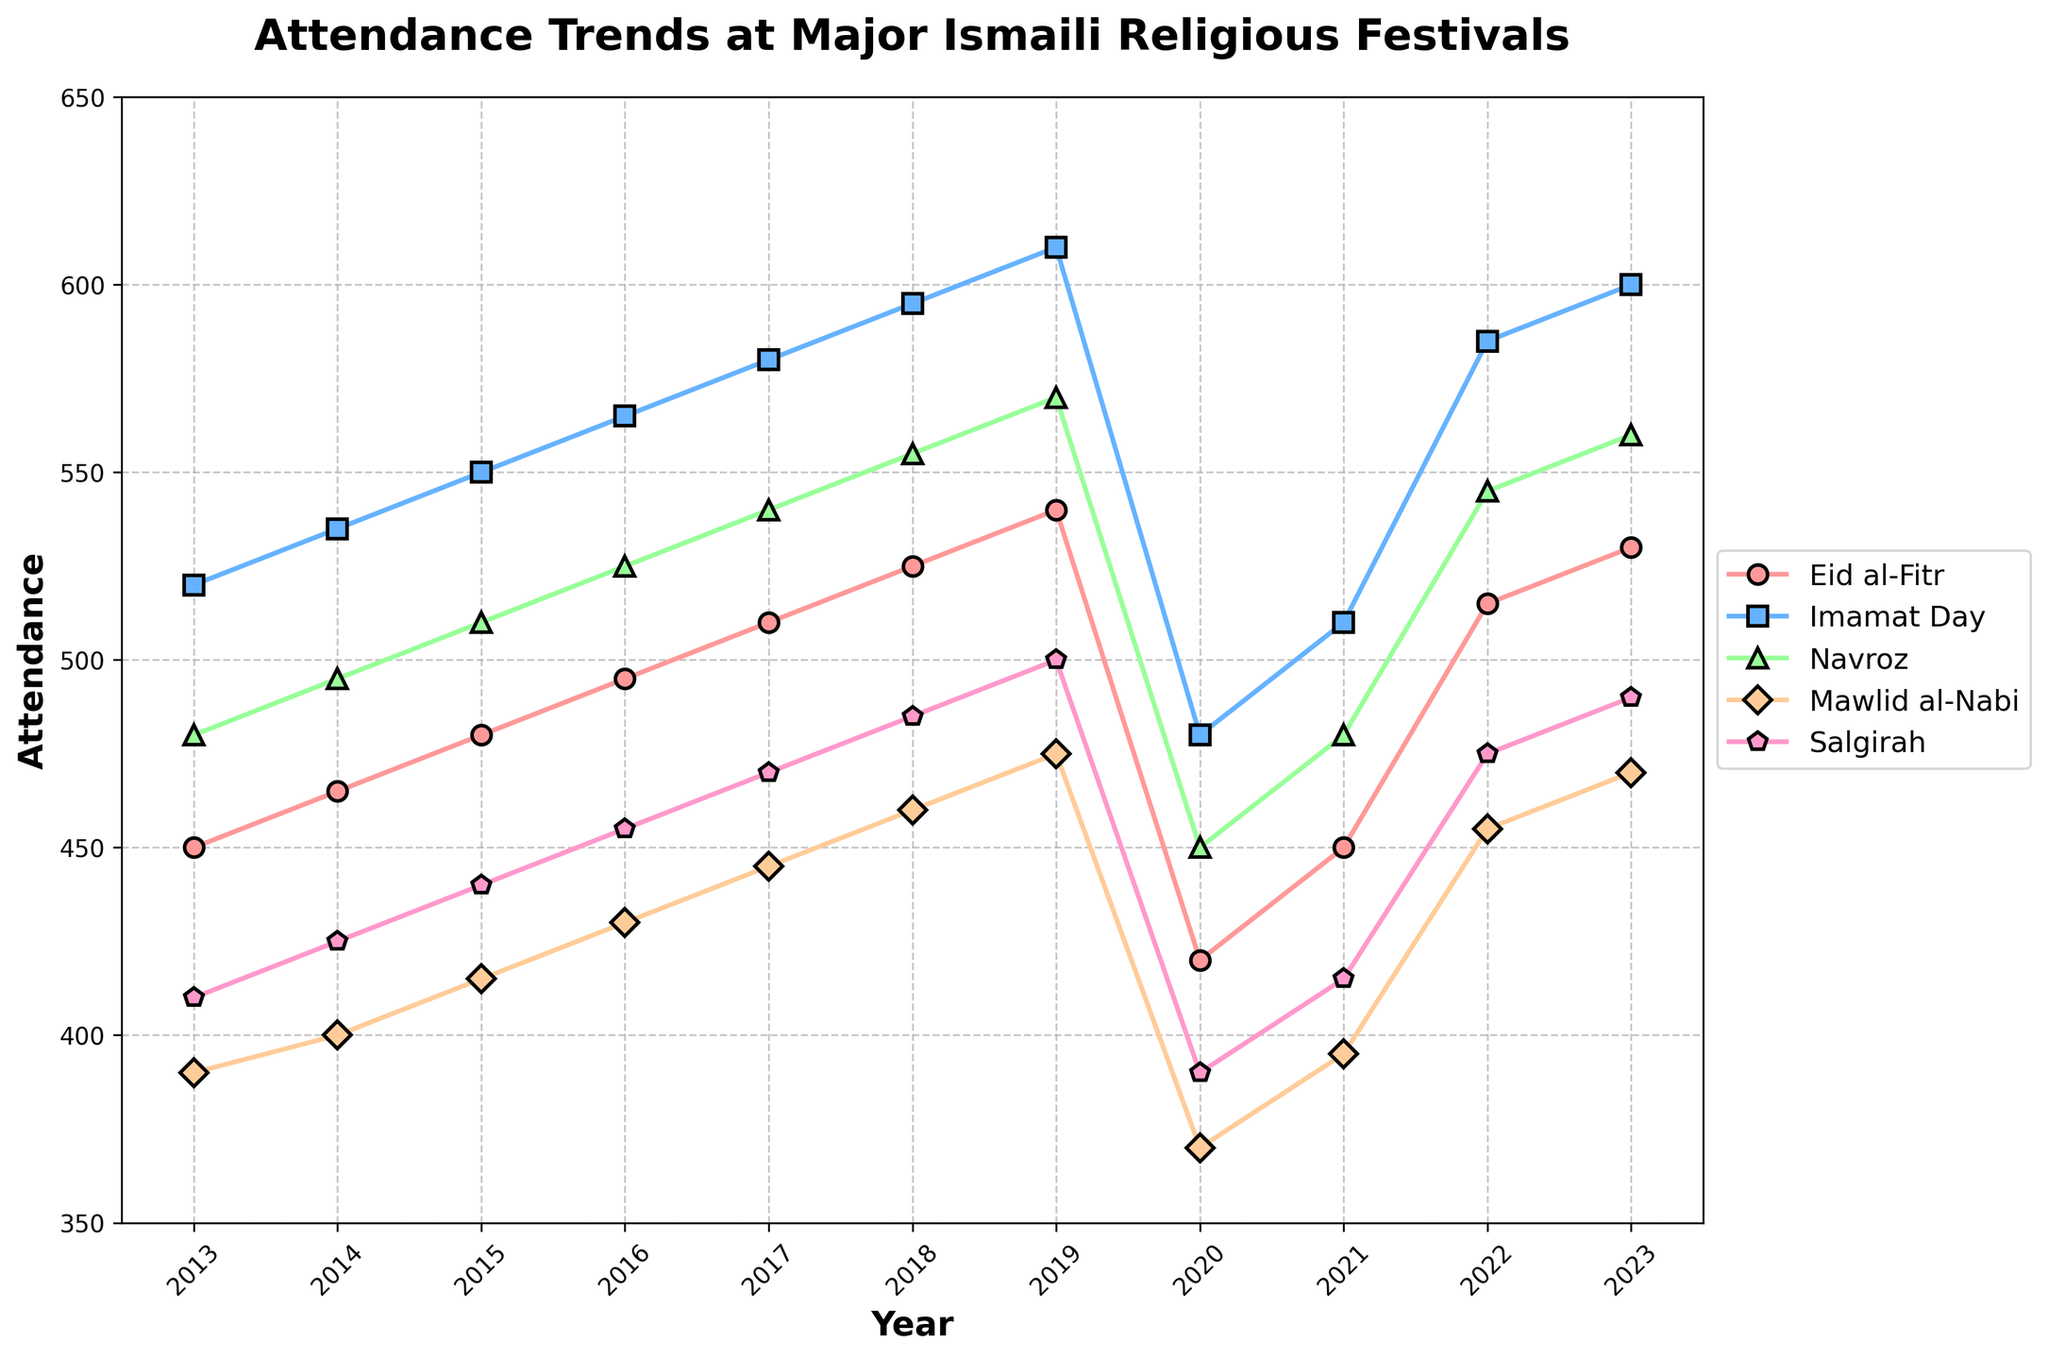In which year was the attendance for Eid al-Fitr the lowest? To find the lowest attendance, we look at the line corresponding to Eid al-Fitr and identify the year with the lowest point on that line. The lowest attendance for Eid al-Fitr was in 2020.
Answer: 2020 Compare the attendance trends for Eid al-Fitr and Imamat Day between 2019 and 2020. Which event saw a greater decline in attendance? To determine this, we calculate the difference in attendance for both events from 2019 to 2020. Eid al-Fitr dropped from 540 to 420 (a decline of 120), while Imamat Day dropped from 610 to 480 (a decline of 130). Hence, Imamat Day saw a greater decline in attendance.
Answer: Imamat Day What is the average attendance for Navroz over the last decade? To find the average, sum the attendances for Navroz from 2013 to 2023: (480 + 495 + 510 + 525 + 540 + 555 + 570 + 450 + 480 + 545 + 560 = 5710). The average is 5710 / 11 = 519.1.
Answer: 519.1 In 2020, which event had the highest attendance? To find this, compare the attendance for all events in 2020. The highest attendance in that year was for Imamat Day with 480 attendees.
Answer: Imamat Day Which event showed a steady increase in attendance from 2013 to 2019? Reviewing the trends, Imamat Day consistently increased its attendance each year from 2013 to 2019.
Answer: Imamat Day By how much did the attendance for Mawlid al-Nabi change from 2019 to 2020? The attendance for Mawlid al-Nabi in 2019 was 475 and in 2020 it was 370. The change is 475 - 370 = 105.
Answer: 105 What was the trend in attendance for Salgirah over the last decade? Observing the line corresponding to Salgirah from 2013 to 2023: it initially increased from 410 to 500 by 2019, dropped in 2020 to 390, but then started increasing again, reaching 490 by 2023.
Answer: Generally increasing What is the difference in attendance between Eid al-Fitr and Navroz in 2017? In 2017, the attendance for Eid al-Fitr was 510 and for Navroz it was 540. The difference is 540 - 510 = 30.
Answer: 30 Which event had the least variation in attendance over the last decade? By visually observing the lines, Mawlid al-Nabi shows the least variation with relatively stable attendance figures.
Answer: Mawlid al-Nabi 